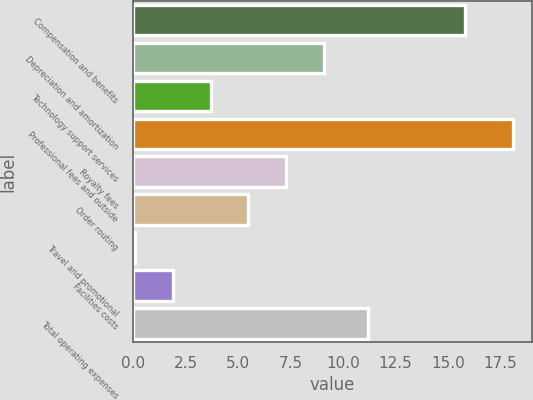<chart> <loc_0><loc_0><loc_500><loc_500><bar_chart><fcel>Compensation and benefits<fcel>Depreciation and amortization<fcel>Technology support services<fcel>Professional fees and outside<fcel>Royalty fees<fcel>Order routing<fcel>Travel and promotional<fcel>Facilities costs<fcel>Total operating expenses<nl><fcel>15.8<fcel>9.1<fcel>3.7<fcel>18.1<fcel>7.3<fcel>5.5<fcel>0.1<fcel>1.9<fcel>11.2<nl></chart> 